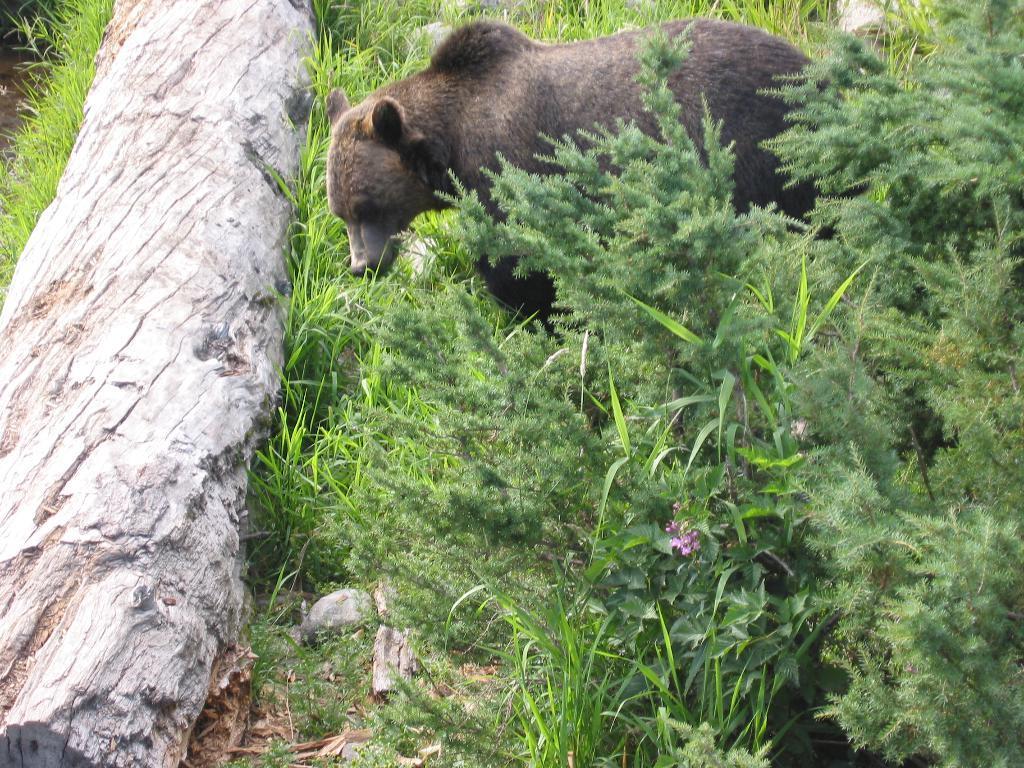Could you give a brief overview of what you see in this image? In this image I can see an animal which is brown and black in color. I can see a huge wooden log, few trees around the animal and few flowers which are pink in color. 